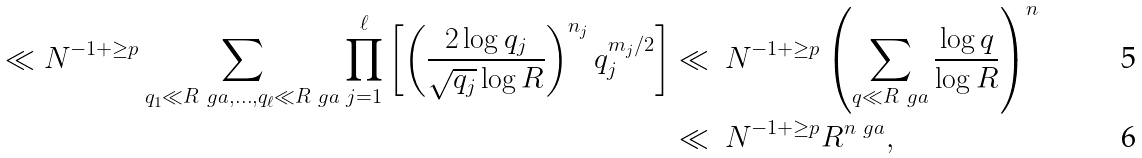<formula> <loc_0><loc_0><loc_500><loc_500>\ll N ^ { - 1 + \geq p } \sum _ { q _ { 1 } \ll R ^ { \ } g a , \dots , q _ { \ell } \ll R ^ { \ } g a } \prod _ { j = 1 } ^ { \ell } \left [ \left ( \frac { 2 \log q _ { j } } { \sqrt { q _ { j } } \log R } \right ) ^ { n _ { j } } q _ { j } ^ { m _ { j } / 2 } \right ] & \ll \ N ^ { - 1 + \geq p } \left ( \sum _ { q \ll R ^ { \ } g a } \frac { \log q } { \log R } \right ) ^ { n } \\ & \ll \ N ^ { - 1 + \geq p } R ^ { n \ g a } ,</formula> 